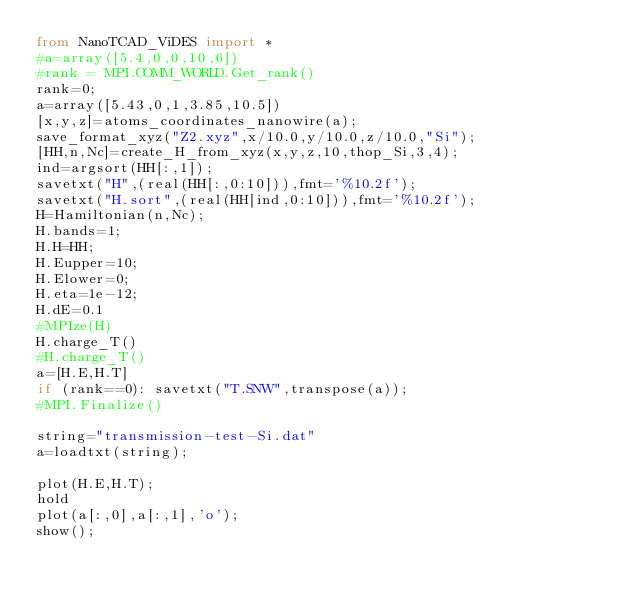<code> <loc_0><loc_0><loc_500><loc_500><_Python_>from NanoTCAD_ViDES import *
#a=array([5.4,0,0,10,6])
#rank = MPI.COMM_WORLD.Get_rank()
rank=0;
a=array([5.43,0,1,3.85,10.5])
[x,y,z]=atoms_coordinates_nanowire(a);
save_format_xyz("Z2.xyz",x/10.0,y/10.0,z/10.0,"Si");
[HH,n,Nc]=create_H_from_xyz(x,y,z,10,thop_Si,3,4);
ind=argsort(HH[:,1]);
savetxt("H",(real(HH[:,0:10])),fmt='%10.2f');
savetxt("H.sort",(real(HH[ind,0:10])),fmt='%10.2f');
H=Hamiltonian(n,Nc);
H.bands=1;
H.H=HH;
H.Eupper=10;
H.Elower=0;
H.eta=1e-12;
H.dE=0.1
#MPIze(H)
H.charge_T()
#H.charge_T()
a=[H.E,H.T]
if (rank==0): savetxt("T.SNW",transpose(a));
#MPI.Finalize()

string="transmission-test-Si.dat" 
a=loadtxt(string);
    
plot(H.E,H.T);
hold
plot(a[:,0],a[:,1],'o');
show();
</code> 